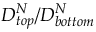Convert formula to latex. <formula><loc_0><loc_0><loc_500><loc_500>{ D _ { t o p } ^ { N } } / { D _ { b o t t o m } ^ { N } }</formula> 